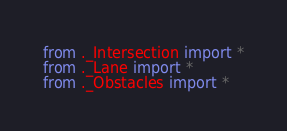Convert code to text. <code><loc_0><loc_0><loc_500><loc_500><_Python_>from ._Intersection import *
from ._Lane import *
from ._Obstacles import *
</code> 